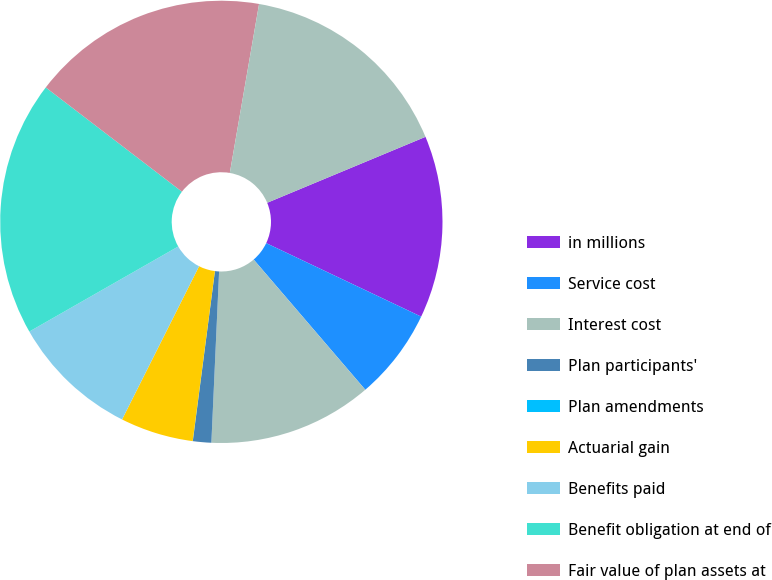Convert chart. <chart><loc_0><loc_0><loc_500><loc_500><pie_chart><fcel>in millions<fcel>Service cost<fcel>Interest cost<fcel>Plan participants'<fcel>Plan amendments<fcel>Actuarial gain<fcel>Benefits paid<fcel>Benefit obligation at end of<fcel>Fair value of plan assets at<fcel>(Loss) / Gain on plan assets<nl><fcel>13.33%<fcel>6.67%<fcel>12.0%<fcel>1.34%<fcel>0.01%<fcel>5.34%<fcel>9.33%<fcel>18.66%<fcel>17.33%<fcel>15.99%<nl></chart> 